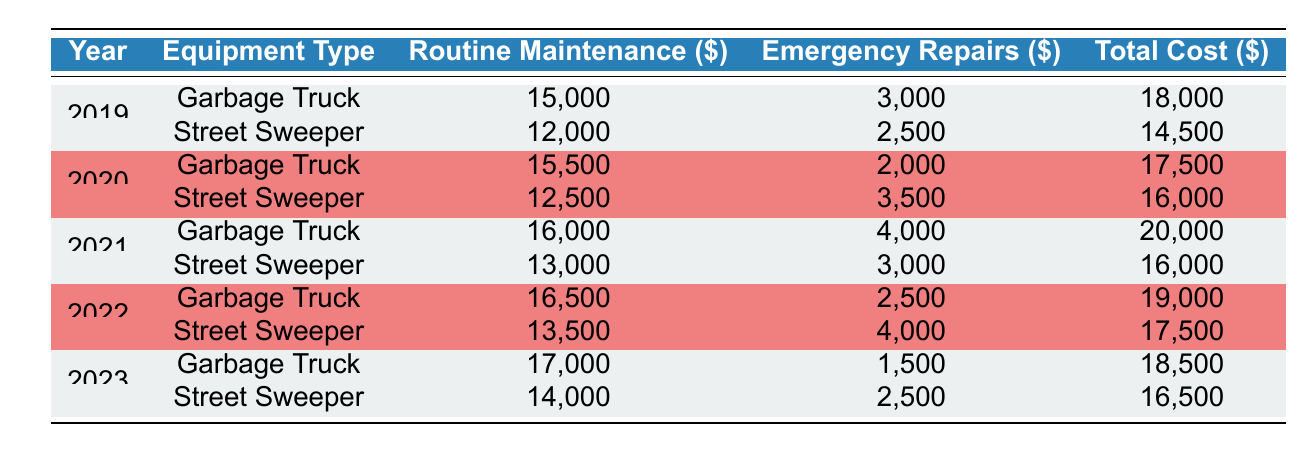What was the total maintenance cost for the Street Sweeper in 2021? From the table, I can find the entry for the Street Sweeper in 2021, which shows the total cost as 16,000.
Answer: 16,000 What equipment had the highest routine maintenance cost in 2020? In 2020, the Garbage Truck had a routine maintenance cost of 15,500, while the Street Sweeper had 12,500. Therefore, the Garbage Truck had the highest routine maintenance cost.
Answer: Garbage Truck What was the average total cost of the Garbage Truck over the five years? The total costs for the Garbage Truck over five years are: 18,000 (2019), 17,500 (2020), 20,000 (2021), 19,000 (2022), and 18,500 (2023). Summing these gives 18,000 + 17,500 + 20,000 + 19,000 + 18,500 = 93,000, and then dividing by 5 results in an average of 18,600.
Answer: 18,600 Is the total maintenance cost for the Street Sweeper in 2022 greater than the total maintenance cost for the Garbage Truck in 2021? The total maintenance cost for the Street Sweeper in 2022 is 17,500, and the cost for the Garbage Truck in 2021 is 20,000. Since 17,500 is less than 20,000, the statement is false.
Answer: No What was the total cost difference between the Street Sweeper and Garbage Truck in 2023? For 2023, the total cost for the Garbage Truck is 18,500 and for the Street Sweeper is 16,500. The difference is 18,500 - 16,500 = 2,000.
Answer: 2,000 In which year was the Emergency Repair cost for the Garbage Truck the lowest? Looking at the table, the Emergency Repair costs for the Garbage Truck are: 3,000 (2019), 2,000 (2020), 4,000 (2021), 2,500 (2022), and 1,500 (2023). The lowest cost is 1,500 in 2023.
Answer: 2023 What was the increase in routine maintenance costs for the Street Sweeper from 2019 to 2021? The routine maintenance cost for the Street Sweeper in 2019 is 12,000, and in 2021 it is 13,000. The increase is 13,000 - 12,000 = 1,000.
Answer: 1,000 Did overall maintenance costs for both the Garbage Truck and Street Sweeper increase from 2020 to 2021? Total costs for 2020 are 17,500 (Garbage Truck) + 16,000 (Street Sweeper) = 33,500, and for 2021 they are 20,000 (Garbage Truck) + 16,000 (Street Sweeper) = 36,000. The total increased from 33,500 to 36,000, confirming an increase.
Answer: Yes 